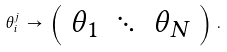<formula> <loc_0><loc_0><loc_500><loc_500>\theta _ { i } ^ { j } \, \rightarrow \, \left ( \begin{array} { c c c } \theta _ { 1 } & \ddots & \theta _ { N } \end{array} \right ) \, .</formula> 